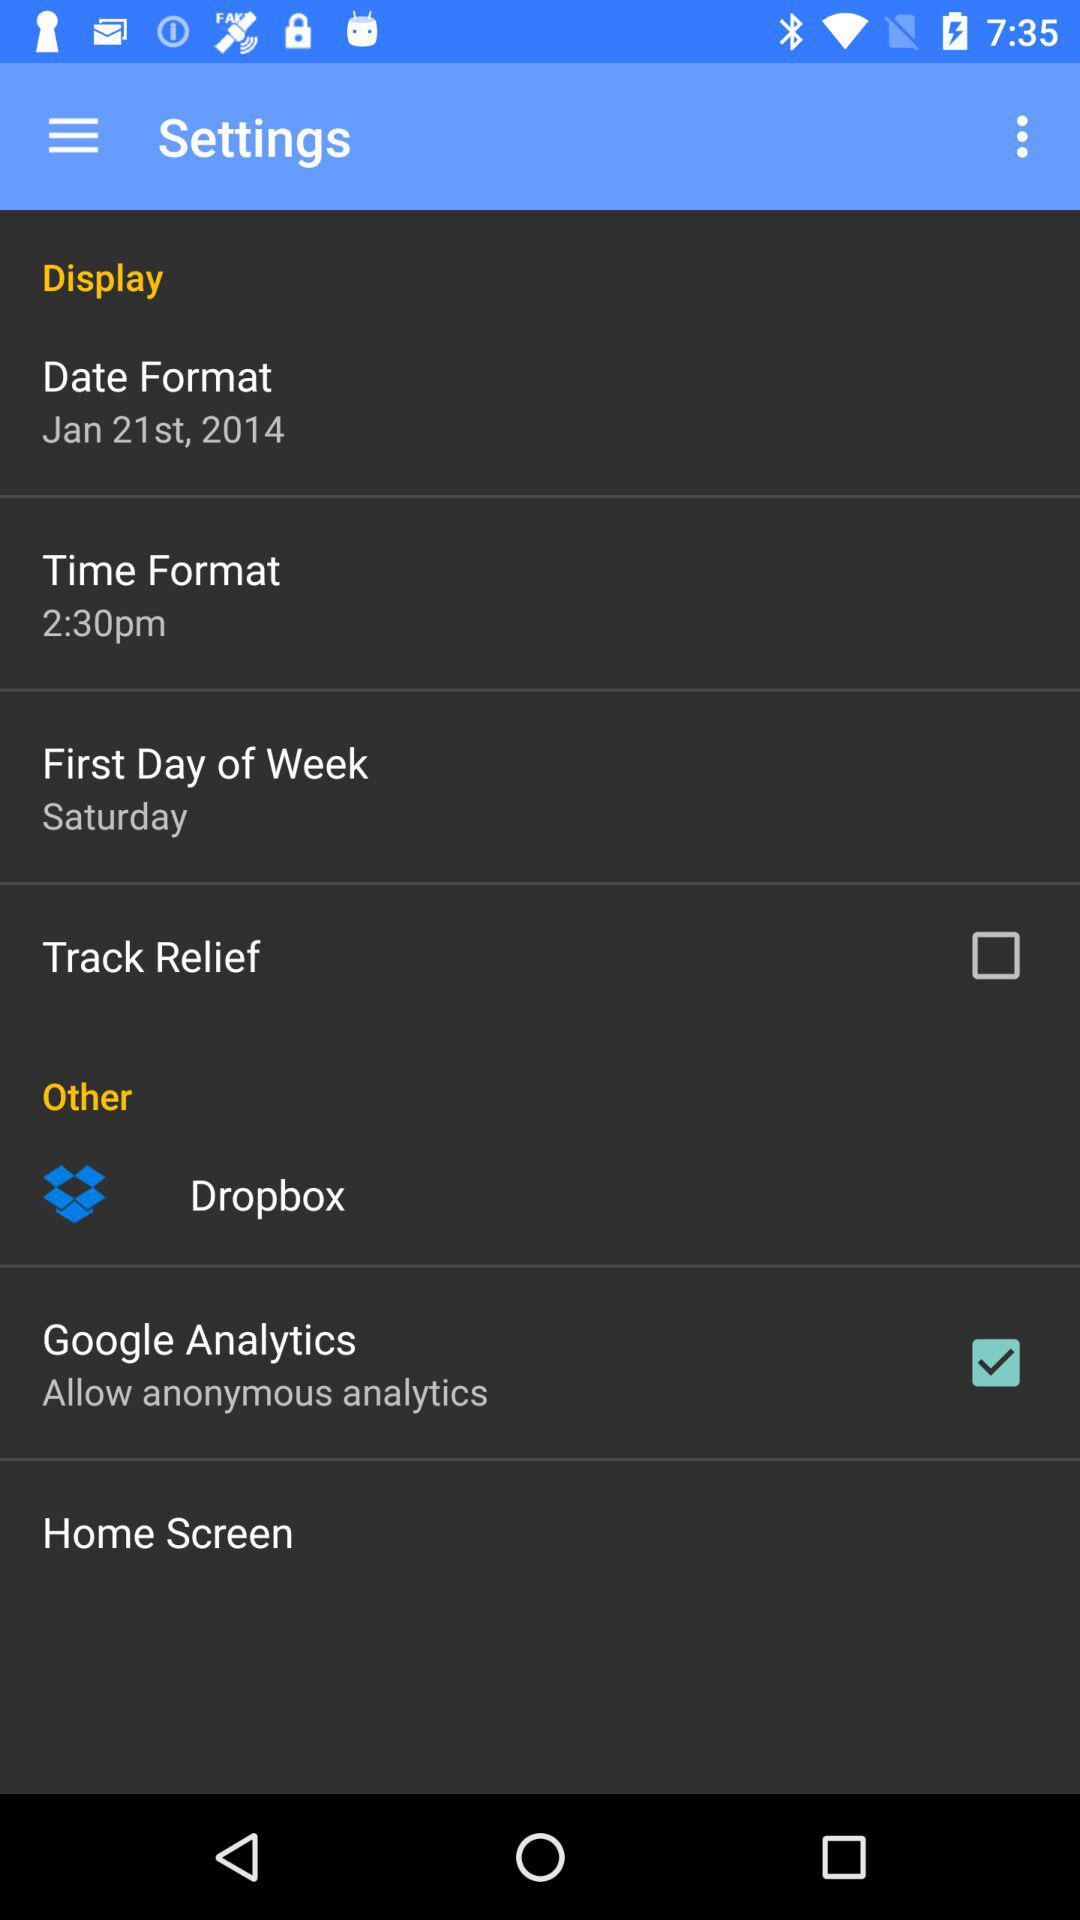What's the date format? The date format is Jan 21st, 2014. 